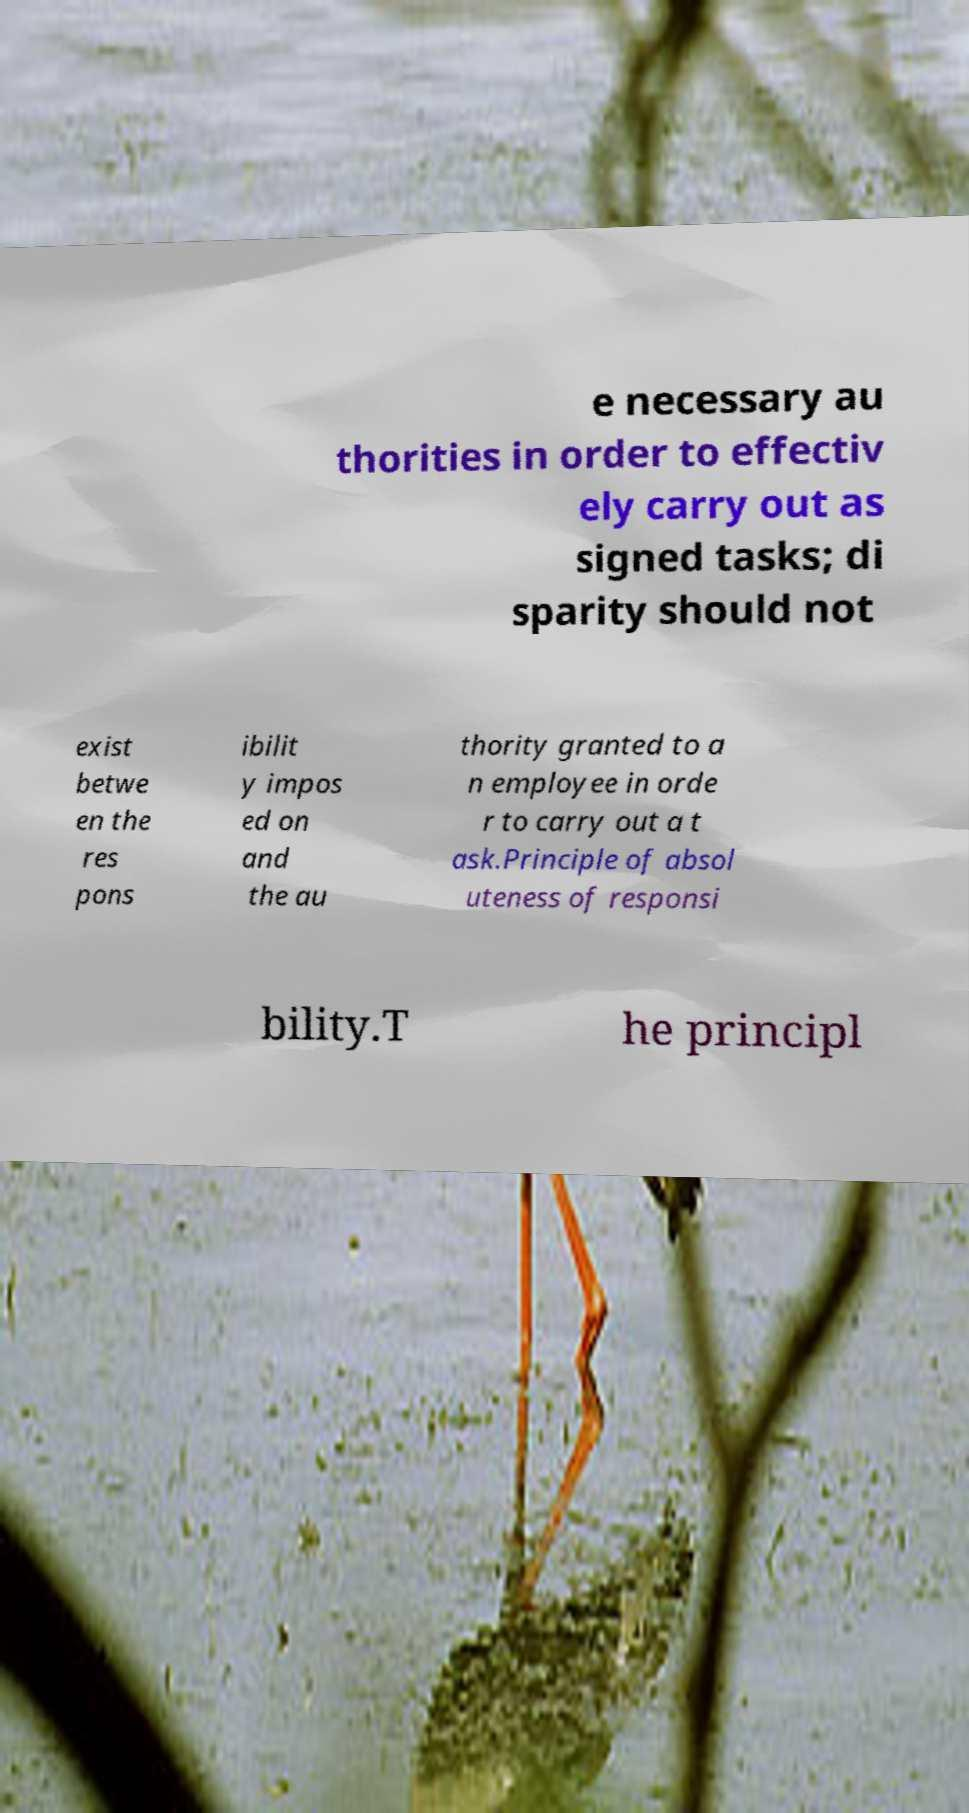Can you read and provide the text displayed in the image?This photo seems to have some interesting text. Can you extract and type it out for me? e necessary au thorities in order to effectiv ely carry out as signed tasks; di sparity should not exist betwe en the res pons ibilit y impos ed on and the au thority granted to a n employee in orde r to carry out a t ask.Principle of absol uteness of responsi bility.T he principl 